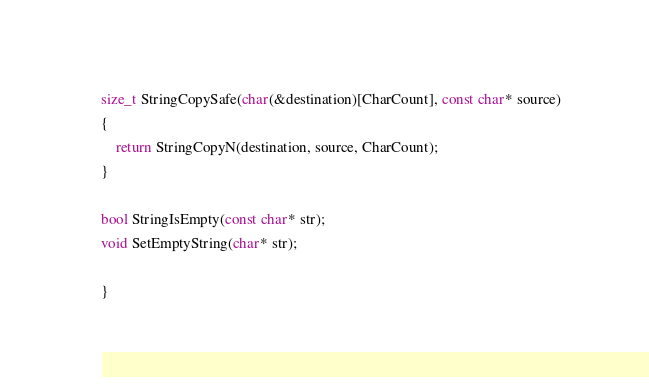Convert code to text. <code><loc_0><loc_0><loc_500><loc_500><_C++_>size_t StringCopySafe(char(&destination)[CharCount], const char* source)
{
	return StringCopyN(destination, source, CharCount);
}

bool StringIsEmpty(const char* str);
void SetEmptyString(char* str);

}
</code> 